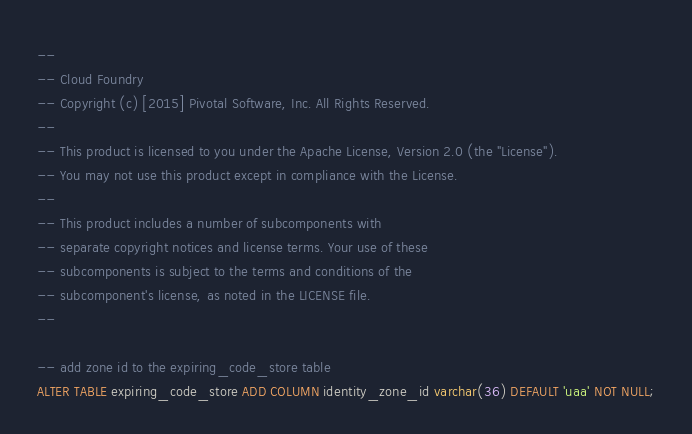<code> <loc_0><loc_0><loc_500><loc_500><_SQL_>--
-- Cloud Foundry
-- Copyright (c) [2015] Pivotal Software, Inc. All Rights Reserved.
--
-- This product is licensed to you under the Apache License, Version 2.0 (the "License").
-- You may not use this product except in compliance with the License.
--
-- This product includes a number of subcomponents with
-- separate copyright notices and license terms. Your use of these
-- subcomponents is subject to the terms and conditions of the
-- subcomponent's license, as noted in the LICENSE file.
--

-- add zone id to the expiring_code_store table
ALTER TABLE expiring_code_store ADD COLUMN identity_zone_id varchar(36) DEFAULT 'uaa' NOT NULL;
</code> 